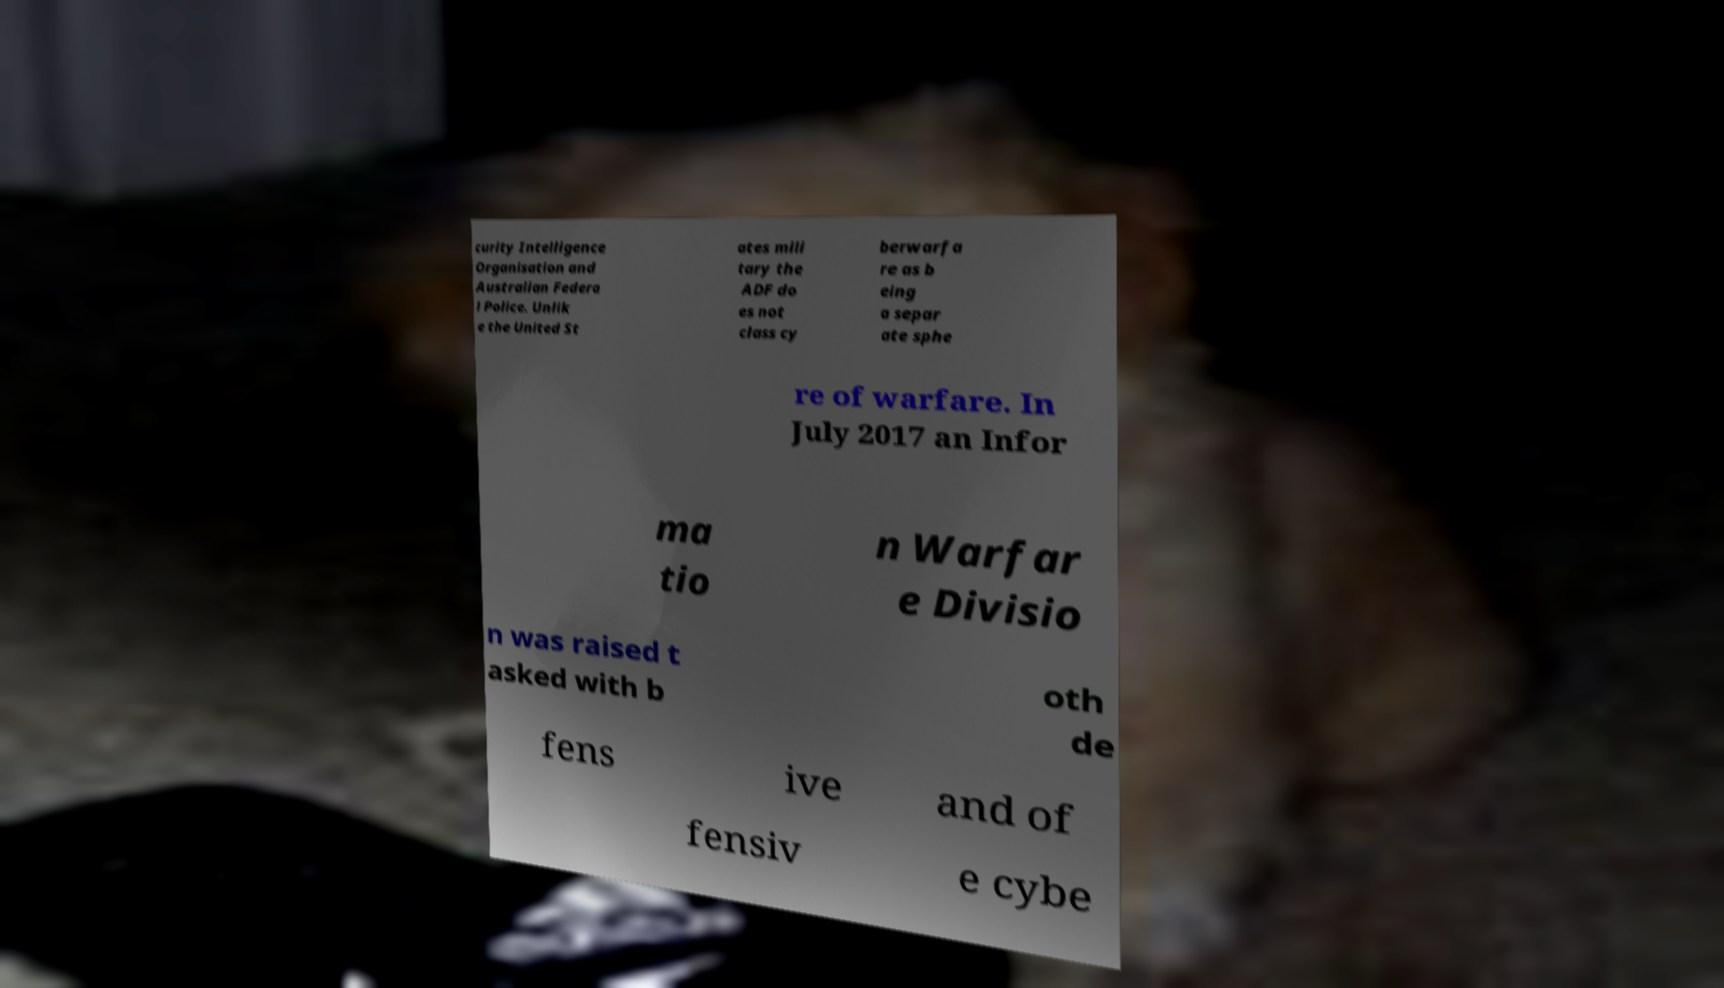Could you extract and type out the text from this image? curity Intelligence Organisation and Australian Federa l Police. Unlik e the United St ates mili tary the ADF do es not class cy berwarfa re as b eing a separ ate sphe re of warfare. In July 2017 an Infor ma tio n Warfar e Divisio n was raised t asked with b oth de fens ive and of fensiv e cybe 